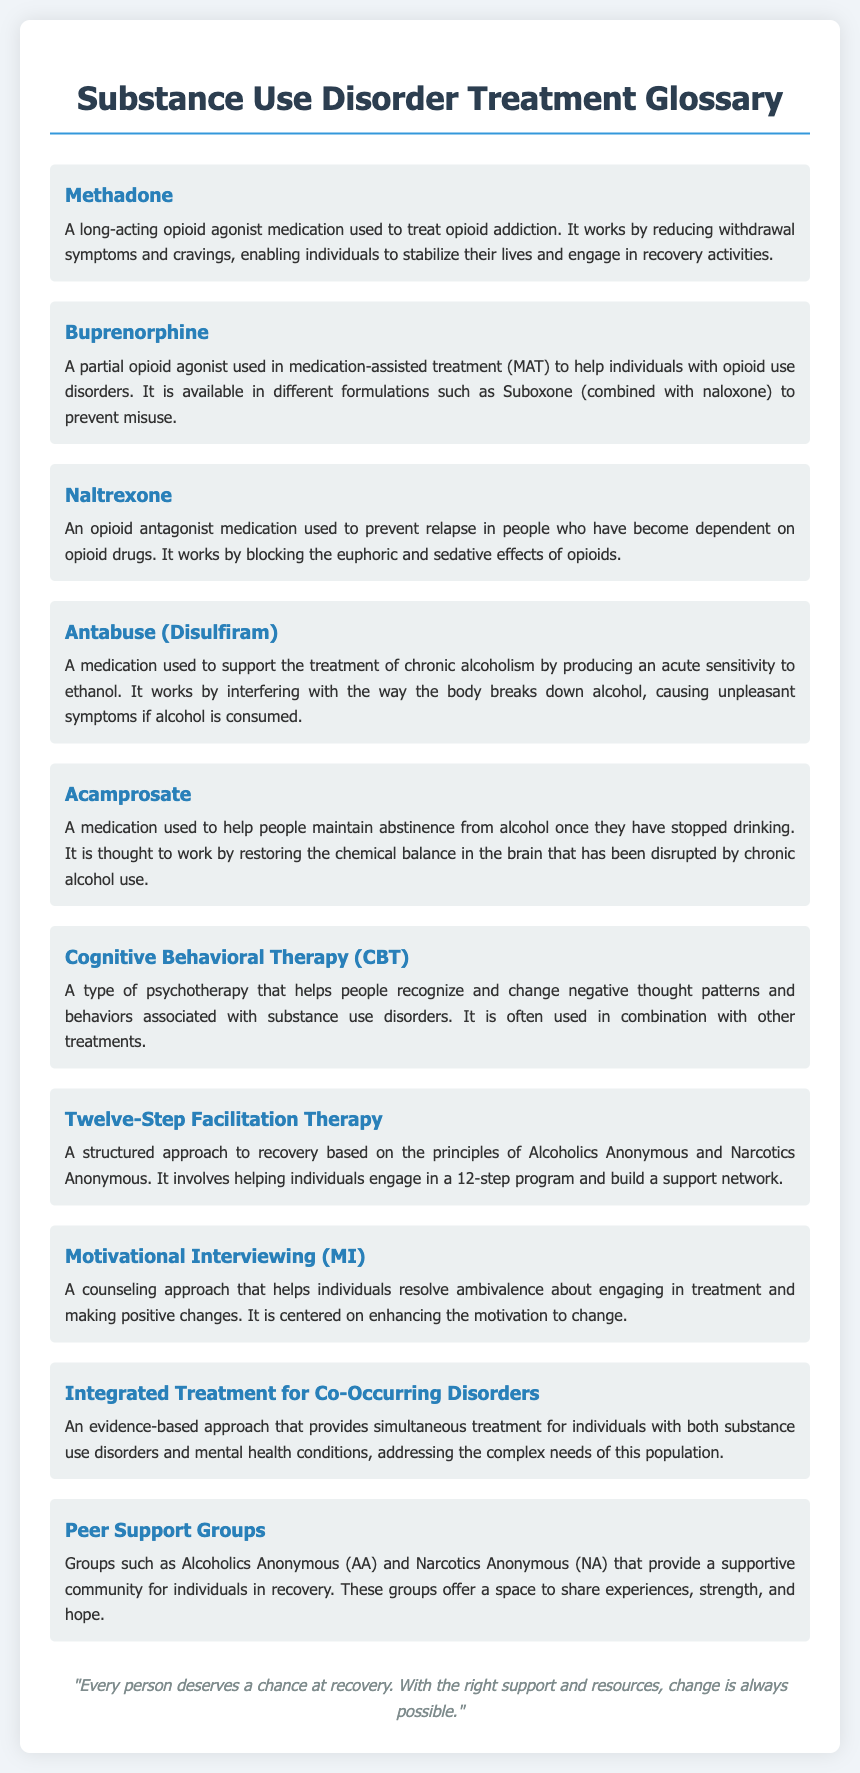What is Methadone? Methadone is described in the document as a long-acting opioid agonist medication used to treat opioid addiction.
Answer: A long-acting opioid agonist medication What does Naltrexone do? The document states that Naltrexone is used to prevent relapse in people dependent on opioid drugs by blocking euphoric effects.
Answer: Prevent relapse What medication is used for chronic alcoholism? The document mentions Antabuse (Disulfiram) as a medication used to support the treatment of chronic alcoholism.
Answer: Antabuse (Disulfiram) How many types of therapies are listed in the document? The document lists multiple types of therapies, such as Cognitive Behavioral Therapy, Twelve-Step Facilitation Therapy, and Motivational Interviewing. Counting these provides three specific therapies.
Answer: Three What is the goal of Acamprosate? Acamprosate is mentioned as a medication to help people maintain abstinence from alcohol once they have stopped drinking.
Answer: Maintain abstinence What type of support do Peer Support Groups offer? The document notes that Peer Support Groups provide a supportive community for sharing experiences and hope among individuals in recovery.
Answer: Supportive community Which therapy enhances motivation to change? The document identifies Motivational Interviewing (MI) as the therapy that enhances the motivation to change.
Answer: Motivational Interviewing (MI) What is Integrated Treatment for Co-Occurring Disorders? The document defines Integrated Treatment for Co-Occurring Disorders as an evidence-based approach that treats individuals with both substance use and mental health conditions simultaneously.
Answer: Evidence-based approach What principle does Twelve-Step Facilitation Therapy follow? The document indicates that Twelve-Step Facilitation Therapy is based on the principles of Alcoholics Anonymous and Narcotics Anonymous.
Answer: Principles of Alcoholics Anonymous and Narcotics Anonymous 